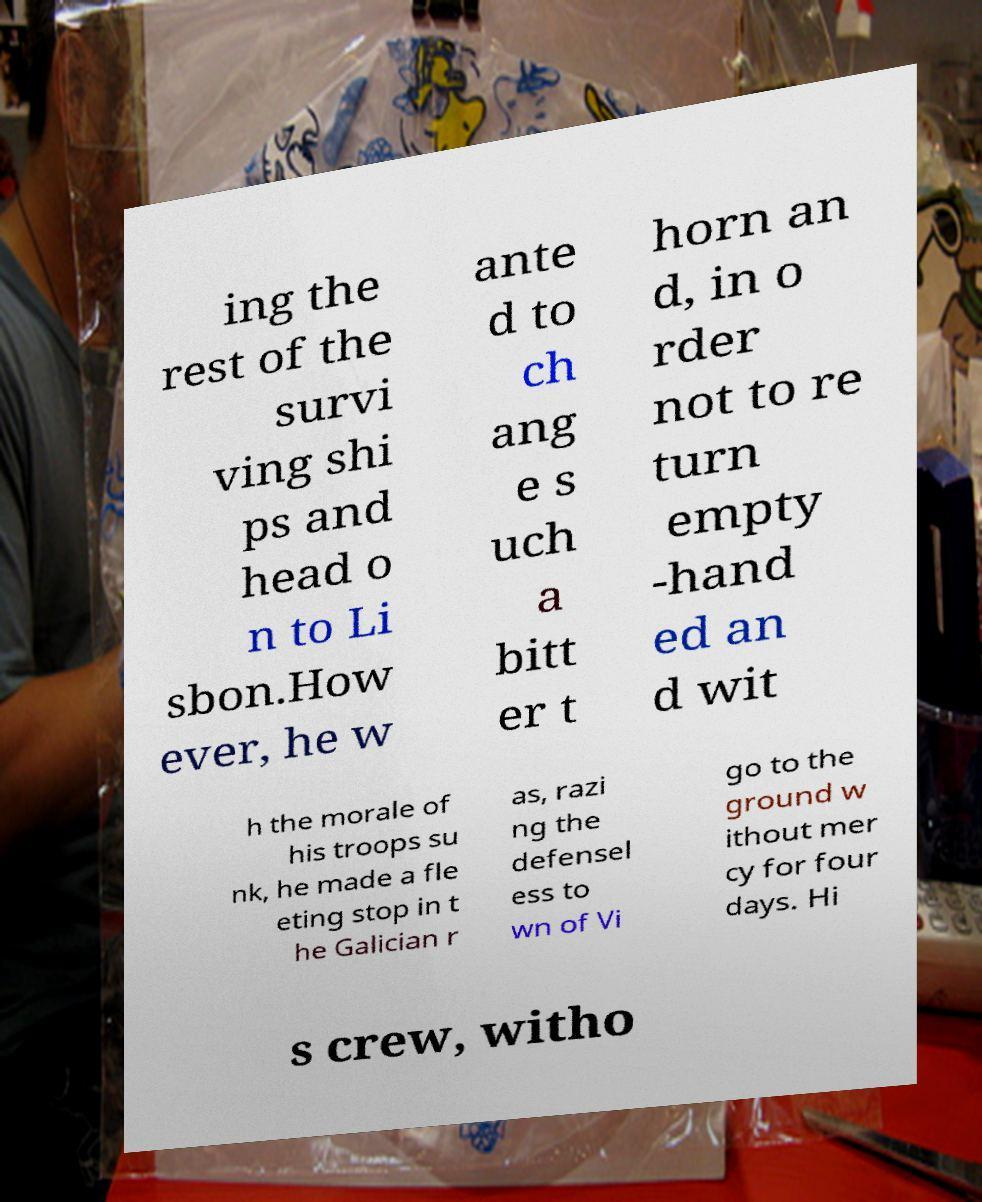Could you extract and type out the text from this image? ing the rest of the survi ving shi ps and head o n to Li sbon.How ever, he w ante d to ch ang e s uch a bitt er t horn an d, in o rder not to re turn empty -hand ed an d wit h the morale of his troops su nk, he made a fle eting stop in t he Galician r as, razi ng the defensel ess to wn of Vi go to the ground w ithout mer cy for four days. Hi s crew, witho 